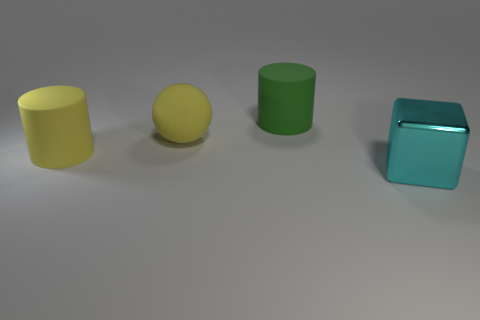Subtract 1 cylinders. How many cylinders are left? 1 Add 2 yellow spheres. How many objects exist? 6 Add 3 large green rubber things. How many large green rubber things exist? 4 Subtract 0 red balls. How many objects are left? 4 Subtract all red blocks. Subtract all gray cylinders. How many blocks are left? 1 Subtract all green blocks. How many yellow cylinders are left? 1 Subtract all shiny cylinders. Subtract all yellow spheres. How many objects are left? 3 Add 1 cubes. How many cubes are left? 2 